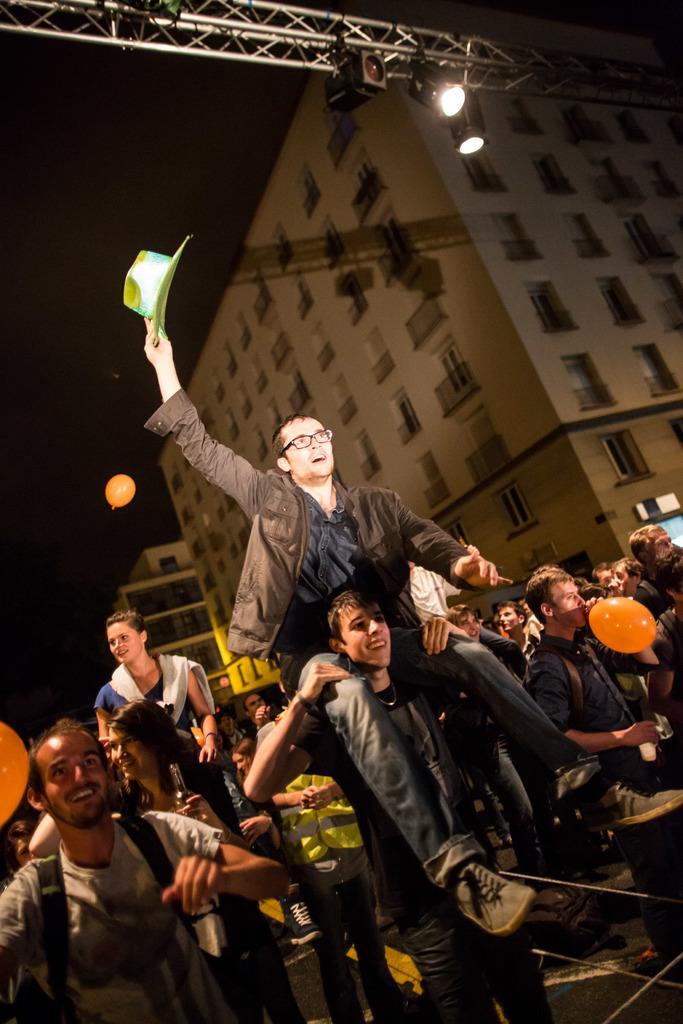Describe this image in one or two sentences. In this image we can see a few people, two of them are holding balloons, there is a person sitting on another person's shoulders, and he is holding a hat there is a pole, there are buildings, windows, and the background is dark. 